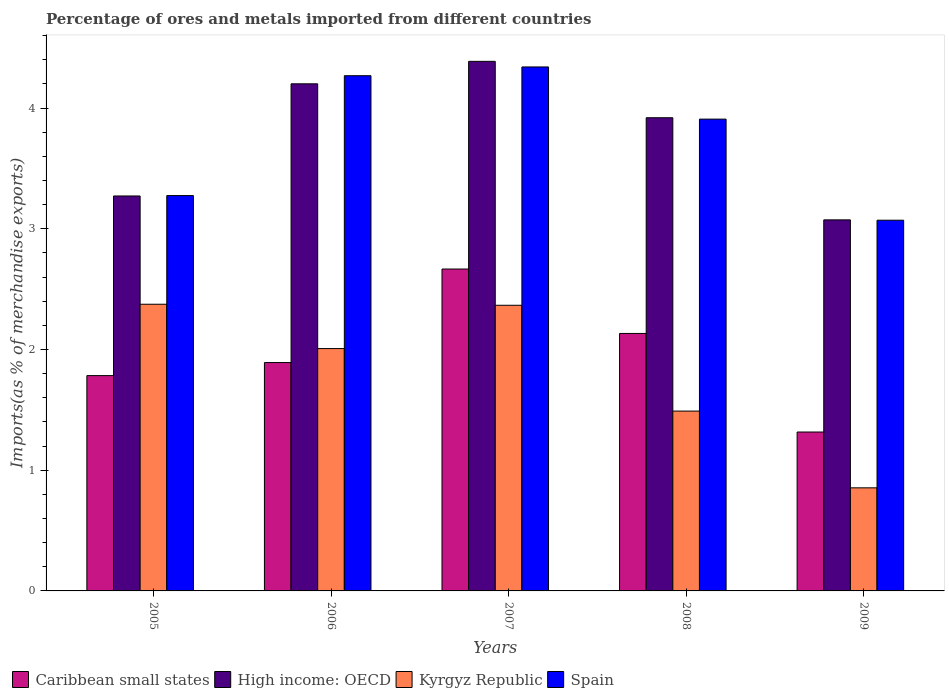How many different coloured bars are there?
Provide a short and direct response. 4. How many groups of bars are there?
Make the answer very short. 5. Are the number of bars per tick equal to the number of legend labels?
Your answer should be compact. Yes. What is the percentage of imports to different countries in High income: OECD in 2008?
Give a very brief answer. 3.92. Across all years, what is the maximum percentage of imports to different countries in Spain?
Keep it short and to the point. 4.34. Across all years, what is the minimum percentage of imports to different countries in Kyrgyz Republic?
Offer a terse response. 0.85. In which year was the percentage of imports to different countries in Kyrgyz Republic maximum?
Ensure brevity in your answer.  2005. In which year was the percentage of imports to different countries in High income: OECD minimum?
Your answer should be very brief. 2009. What is the total percentage of imports to different countries in Kyrgyz Republic in the graph?
Provide a succinct answer. 9.09. What is the difference between the percentage of imports to different countries in High income: OECD in 2007 and that in 2008?
Make the answer very short. 0.47. What is the difference between the percentage of imports to different countries in Kyrgyz Republic in 2007 and the percentage of imports to different countries in High income: OECD in 2008?
Your response must be concise. -1.55. What is the average percentage of imports to different countries in High income: OECD per year?
Your response must be concise. 3.77. In the year 2008, what is the difference between the percentage of imports to different countries in High income: OECD and percentage of imports to different countries in Kyrgyz Republic?
Your response must be concise. 2.43. What is the ratio of the percentage of imports to different countries in Caribbean small states in 2005 to that in 2006?
Offer a very short reply. 0.94. Is the difference between the percentage of imports to different countries in High income: OECD in 2005 and 2009 greater than the difference between the percentage of imports to different countries in Kyrgyz Republic in 2005 and 2009?
Offer a terse response. No. What is the difference between the highest and the second highest percentage of imports to different countries in Spain?
Your response must be concise. 0.07. What is the difference between the highest and the lowest percentage of imports to different countries in High income: OECD?
Your answer should be very brief. 1.31. In how many years, is the percentage of imports to different countries in High income: OECD greater than the average percentage of imports to different countries in High income: OECD taken over all years?
Your answer should be very brief. 3. Is the sum of the percentage of imports to different countries in Caribbean small states in 2008 and 2009 greater than the maximum percentage of imports to different countries in High income: OECD across all years?
Your answer should be very brief. No. Is it the case that in every year, the sum of the percentage of imports to different countries in Kyrgyz Republic and percentage of imports to different countries in Spain is greater than the sum of percentage of imports to different countries in Caribbean small states and percentage of imports to different countries in High income: OECD?
Your answer should be very brief. Yes. What does the 1st bar from the left in 2008 represents?
Provide a short and direct response. Caribbean small states. What does the 4th bar from the right in 2007 represents?
Offer a terse response. Caribbean small states. Are all the bars in the graph horizontal?
Offer a very short reply. No. What is the difference between two consecutive major ticks on the Y-axis?
Your answer should be very brief. 1. Does the graph contain grids?
Offer a terse response. No. Where does the legend appear in the graph?
Offer a terse response. Bottom left. What is the title of the graph?
Ensure brevity in your answer.  Percentage of ores and metals imported from different countries. Does "Cambodia" appear as one of the legend labels in the graph?
Provide a succinct answer. No. What is the label or title of the Y-axis?
Your response must be concise. Imports(as % of merchandise exports). What is the Imports(as % of merchandise exports) of Caribbean small states in 2005?
Your answer should be compact. 1.78. What is the Imports(as % of merchandise exports) of High income: OECD in 2005?
Offer a terse response. 3.27. What is the Imports(as % of merchandise exports) of Kyrgyz Republic in 2005?
Your answer should be very brief. 2.37. What is the Imports(as % of merchandise exports) of Spain in 2005?
Your response must be concise. 3.28. What is the Imports(as % of merchandise exports) of Caribbean small states in 2006?
Provide a succinct answer. 1.89. What is the Imports(as % of merchandise exports) of High income: OECD in 2006?
Ensure brevity in your answer.  4.2. What is the Imports(as % of merchandise exports) of Kyrgyz Republic in 2006?
Give a very brief answer. 2.01. What is the Imports(as % of merchandise exports) in Spain in 2006?
Offer a terse response. 4.27. What is the Imports(as % of merchandise exports) in Caribbean small states in 2007?
Your answer should be compact. 2.67. What is the Imports(as % of merchandise exports) in High income: OECD in 2007?
Provide a succinct answer. 4.39. What is the Imports(as % of merchandise exports) of Kyrgyz Republic in 2007?
Keep it short and to the point. 2.37. What is the Imports(as % of merchandise exports) of Spain in 2007?
Keep it short and to the point. 4.34. What is the Imports(as % of merchandise exports) in Caribbean small states in 2008?
Make the answer very short. 2.13. What is the Imports(as % of merchandise exports) of High income: OECD in 2008?
Your answer should be compact. 3.92. What is the Imports(as % of merchandise exports) of Kyrgyz Republic in 2008?
Your answer should be very brief. 1.49. What is the Imports(as % of merchandise exports) in Spain in 2008?
Ensure brevity in your answer.  3.91. What is the Imports(as % of merchandise exports) of Caribbean small states in 2009?
Offer a very short reply. 1.32. What is the Imports(as % of merchandise exports) in High income: OECD in 2009?
Offer a terse response. 3.07. What is the Imports(as % of merchandise exports) of Kyrgyz Republic in 2009?
Keep it short and to the point. 0.85. What is the Imports(as % of merchandise exports) of Spain in 2009?
Your answer should be compact. 3.07. Across all years, what is the maximum Imports(as % of merchandise exports) of Caribbean small states?
Keep it short and to the point. 2.67. Across all years, what is the maximum Imports(as % of merchandise exports) in High income: OECD?
Provide a succinct answer. 4.39. Across all years, what is the maximum Imports(as % of merchandise exports) in Kyrgyz Republic?
Give a very brief answer. 2.37. Across all years, what is the maximum Imports(as % of merchandise exports) of Spain?
Offer a terse response. 4.34. Across all years, what is the minimum Imports(as % of merchandise exports) of Caribbean small states?
Make the answer very short. 1.32. Across all years, what is the minimum Imports(as % of merchandise exports) in High income: OECD?
Your answer should be compact. 3.07. Across all years, what is the minimum Imports(as % of merchandise exports) in Kyrgyz Republic?
Ensure brevity in your answer.  0.85. Across all years, what is the minimum Imports(as % of merchandise exports) of Spain?
Give a very brief answer. 3.07. What is the total Imports(as % of merchandise exports) in Caribbean small states in the graph?
Give a very brief answer. 9.79. What is the total Imports(as % of merchandise exports) in High income: OECD in the graph?
Make the answer very short. 18.85. What is the total Imports(as % of merchandise exports) in Kyrgyz Republic in the graph?
Ensure brevity in your answer.  9.09. What is the total Imports(as % of merchandise exports) of Spain in the graph?
Ensure brevity in your answer.  18.86. What is the difference between the Imports(as % of merchandise exports) of Caribbean small states in 2005 and that in 2006?
Your answer should be very brief. -0.11. What is the difference between the Imports(as % of merchandise exports) of High income: OECD in 2005 and that in 2006?
Ensure brevity in your answer.  -0.93. What is the difference between the Imports(as % of merchandise exports) in Kyrgyz Republic in 2005 and that in 2006?
Make the answer very short. 0.37. What is the difference between the Imports(as % of merchandise exports) in Spain in 2005 and that in 2006?
Your answer should be very brief. -0.99. What is the difference between the Imports(as % of merchandise exports) of Caribbean small states in 2005 and that in 2007?
Give a very brief answer. -0.88. What is the difference between the Imports(as % of merchandise exports) in High income: OECD in 2005 and that in 2007?
Offer a terse response. -1.12. What is the difference between the Imports(as % of merchandise exports) in Kyrgyz Republic in 2005 and that in 2007?
Your response must be concise. 0.01. What is the difference between the Imports(as % of merchandise exports) of Spain in 2005 and that in 2007?
Give a very brief answer. -1.07. What is the difference between the Imports(as % of merchandise exports) of Caribbean small states in 2005 and that in 2008?
Give a very brief answer. -0.35. What is the difference between the Imports(as % of merchandise exports) of High income: OECD in 2005 and that in 2008?
Your response must be concise. -0.65. What is the difference between the Imports(as % of merchandise exports) of Kyrgyz Republic in 2005 and that in 2008?
Provide a short and direct response. 0.89. What is the difference between the Imports(as % of merchandise exports) of Spain in 2005 and that in 2008?
Provide a succinct answer. -0.63. What is the difference between the Imports(as % of merchandise exports) in Caribbean small states in 2005 and that in 2009?
Make the answer very short. 0.47. What is the difference between the Imports(as % of merchandise exports) in High income: OECD in 2005 and that in 2009?
Your answer should be compact. 0.2. What is the difference between the Imports(as % of merchandise exports) of Kyrgyz Republic in 2005 and that in 2009?
Your answer should be compact. 1.52. What is the difference between the Imports(as % of merchandise exports) of Spain in 2005 and that in 2009?
Your answer should be compact. 0.2. What is the difference between the Imports(as % of merchandise exports) in Caribbean small states in 2006 and that in 2007?
Give a very brief answer. -0.77. What is the difference between the Imports(as % of merchandise exports) in High income: OECD in 2006 and that in 2007?
Ensure brevity in your answer.  -0.19. What is the difference between the Imports(as % of merchandise exports) of Kyrgyz Republic in 2006 and that in 2007?
Provide a succinct answer. -0.36. What is the difference between the Imports(as % of merchandise exports) in Spain in 2006 and that in 2007?
Provide a succinct answer. -0.07. What is the difference between the Imports(as % of merchandise exports) of Caribbean small states in 2006 and that in 2008?
Offer a very short reply. -0.24. What is the difference between the Imports(as % of merchandise exports) in High income: OECD in 2006 and that in 2008?
Give a very brief answer. 0.28. What is the difference between the Imports(as % of merchandise exports) of Kyrgyz Republic in 2006 and that in 2008?
Offer a very short reply. 0.52. What is the difference between the Imports(as % of merchandise exports) in Spain in 2006 and that in 2008?
Offer a terse response. 0.36. What is the difference between the Imports(as % of merchandise exports) in Caribbean small states in 2006 and that in 2009?
Your answer should be compact. 0.58. What is the difference between the Imports(as % of merchandise exports) in High income: OECD in 2006 and that in 2009?
Your answer should be compact. 1.13. What is the difference between the Imports(as % of merchandise exports) in Kyrgyz Republic in 2006 and that in 2009?
Your answer should be compact. 1.15. What is the difference between the Imports(as % of merchandise exports) in Spain in 2006 and that in 2009?
Keep it short and to the point. 1.2. What is the difference between the Imports(as % of merchandise exports) of Caribbean small states in 2007 and that in 2008?
Provide a succinct answer. 0.53. What is the difference between the Imports(as % of merchandise exports) of High income: OECD in 2007 and that in 2008?
Offer a terse response. 0.47. What is the difference between the Imports(as % of merchandise exports) of Kyrgyz Republic in 2007 and that in 2008?
Make the answer very short. 0.88. What is the difference between the Imports(as % of merchandise exports) of Spain in 2007 and that in 2008?
Ensure brevity in your answer.  0.43. What is the difference between the Imports(as % of merchandise exports) of Caribbean small states in 2007 and that in 2009?
Your response must be concise. 1.35. What is the difference between the Imports(as % of merchandise exports) of High income: OECD in 2007 and that in 2009?
Offer a very short reply. 1.31. What is the difference between the Imports(as % of merchandise exports) of Kyrgyz Republic in 2007 and that in 2009?
Provide a short and direct response. 1.51. What is the difference between the Imports(as % of merchandise exports) in Spain in 2007 and that in 2009?
Offer a very short reply. 1.27. What is the difference between the Imports(as % of merchandise exports) of Caribbean small states in 2008 and that in 2009?
Provide a succinct answer. 0.82. What is the difference between the Imports(as % of merchandise exports) in High income: OECD in 2008 and that in 2009?
Ensure brevity in your answer.  0.85. What is the difference between the Imports(as % of merchandise exports) in Kyrgyz Republic in 2008 and that in 2009?
Ensure brevity in your answer.  0.64. What is the difference between the Imports(as % of merchandise exports) in Spain in 2008 and that in 2009?
Your response must be concise. 0.84. What is the difference between the Imports(as % of merchandise exports) in Caribbean small states in 2005 and the Imports(as % of merchandise exports) in High income: OECD in 2006?
Make the answer very short. -2.42. What is the difference between the Imports(as % of merchandise exports) of Caribbean small states in 2005 and the Imports(as % of merchandise exports) of Kyrgyz Republic in 2006?
Provide a succinct answer. -0.22. What is the difference between the Imports(as % of merchandise exports) of Caribbean small states in 2005 and the Imports(as % of merchandise exports) of Spain in 2006?
Make the answer very short. -2.48. What is the difference between the Imports(as % of merchandise exports) of High income: OECD in 2005 and the Imports(as % of merchandise exports) of Kyrgyz Republic in 2006?
Offer a very short reply. 1.26. What is the difference between the Imports(as % of merchandise exports) in High income: OECD in 2005 and the Imports(as % of merchandise exports) in Spain in 2006?
Make the answer very short. -1. What is the difference between the Imports(as % of merchandise exports) of Kyrgyz Republic in 2005 and the Imports(as % of merchandise exports) of Spain in 2006?
Your response must be concise. -1.89. What is the difference between the Imports(as % of merchandise exports) in Caribbean small states in 2005 and the Imports(as % of merchandise exports) in High income: OECD in 2007?
Give a very brief answer. -2.6. What is the difference between the Imports(as % of merchandise exports) in Caribbean small states in 2005 and the Imports(as % of merchandise exports) in Kyrgyz Republic in 2007?
Your answer should be compact. -0.58. What is the difference between the Imports(as % of merchandise exports) in Caribbean small states in 2005 and the Imports(as % of merchandise exports) in Spain in 2007?
Your response must be concise. -2.56. What is the difference between the Imports(as % of merchandise exports) in High income: OECD in 2005 and the Imports(as % of merchandise exports) in Kyrgyz Republic in 2007?
Provide a short and direct response. 0.91. What is the difference between the Imports(as % of merchandise exports) of High income: OECD in 2005 and the Imports(as % of merchandise exports) of Spain in 2007?
Give a very brief answer. -1.07. What is the difference between the Imports(as % of merchandise exports) of Kyrgyz Republic in 2005 and the Imports(as % of merchandise exports) of Spain in 2007?
Provide a short and direct response. -1.97. What is the difference between the Imports(as % of merchandise exports) of Caribbean small states in 2005 and the Imports(as % of merchandise exports) of High income: OECD in 2008?
Ensure brevity in your answer.  -2.14. What is the difference between the Imports(as % of merchandise exports) of Caribbean small states in 2005 and the Imports(as % of merchandise exports) of Kyrgyz Republic in 2008?
Your response must be concise. 0.29. What is the difference between the Imports(as % of merchandise exports) of Caribbean small states in 2005 and the Imports(as % of merchandise exports) of Spain in 2008?
Ensure brevity in your answer.  -2.12. What is the difference between the Imports(as % of merchandise exports) of High income: OECD in 2005 and the Imports(as % of merchandise exports) of Kyrgyz Republic in 2008?
Make the answer very short. 1.78. What is the difference between the Imports(as % of merchandise exports) in High income: OECD in 2005 and the Imports(as % of merchandise exports) in Spain in 2008?
Provide a succinct answer. -0.64. What is the difference between the Imports(as % of merchandise exports) of Kyrgyz Republic in 2005 and the Imports(as % of merchandise exports) of Spain in 2008?
Your answer should be very brief. -1.53. What is the difference between the Imports(as % of merchandise exports) of Caribbean small states in 2005 and the Imports(as % of merchandise exports) of High income: OECD in 2009?
Ensure brevity in your answer.  -1.29. What is the difference between the Imports(as % of merchandise exports) of Caribbean small states in 2005 and the Imports(as % of merchandise exports) of Kyrgyz Republic in 2009?
Make the answer very short. 0.93. What is the difference between the Imports(as % of merchandise exports) in Caribbean small states in 2005 and the Imports(as % of merchandise exports) in Spain in 2009?
Offer a very short reply. -1.29. What is the difference between the Imports(as % of merchandise exports) in High income: OECD in 2005 and the Imports(as % of merchandise exports) in Kyrgyz Republic in 2009?
Provide a succinct answer. 2.42. What is the difference between the Imports(as % of merchandise exports) of High income: OECD in 2005 and the Imports(as % of merchandise exports) of Spain in 2009?
Offer a terse response. 0.2. What is the difference between the Imports(as % of merchandise exports) of Kyrgyz Republic in 2005 and the Imports(as % of merchandise exports) of Spain in 2009?
Give a very brief answer. -0.7. What is the difference between the Imports(as % of merchandise exports) in Caribbean small states in 2006 and the Imports(as % of merchandise exports) in High income: OECD in 2007?
Make the answer very short. -2.5. What is the difference between the Imports(as % of merchandise exports) in Caribbean small states in 2006 and the Imports(as % of merchandise exports) in Kyrgyz Republic in 2007?
Your answer should be very brief. -0.47. What is the difference between the Imports(as % of merchandise exports) in Caribbean small states in 2006 and the Imports(as % of merchandise exports) in Spain in 2007?
Your response must be concise. -2.45. What is the difference between the Imports(as % of merchandise exports) of High income: OECD in 2006 and the Imports(as % of merchandise exports) of Kyrgyz Republic in 2007?
Make the answer very short. 1.83. What is the difference between the Imports(as % of merchandise exports) of High income: OECD in 2006 and the Imports(as % of merchandise exports) of Spain in 2007?
Your response must be concise. -0.14. What is the difference between the Imports(as % of merchandise exports) of Kyrgyz Republic in 2006 and the Imports(as % of merchandise exports) of Spain in 2007?
Provide a succinct answer. -2.33. What is the difference between the Imports(as % of merchandise exports) of Caribbean small states in 2006 and the Imports(as % of merchandise exports) of High income: OECD in 2008?
Make the answer very short. -2.03. What is the difference between the Imports(as % of merchandise exports) in Caribbean small states in 2006 and the Imports(as % of merchandise exports) in Kyrgyz Republic in 2008?
Offer a terse response. 0.4. What is the difference between the Imports(as % of merchandise exports) in Caribbean small states in 2006 and the Imports(as % of merchandise exports) in Spain in 2008?
Ensure brevity in your answer.  -2.02. What is the difference between the Imports(as % of merchandise exports) in High income: OECD in 2006 and the Imports(as % of merchandise exports) in Kyrgyz Republic in 2008?
Provide a succinct answer. 2.71. What is the difference between the Imports(as % of merchandise exports) of High income: OECD in 2006 and the Imports(as % of merchandise exports) of Spain in 2008?
Provide a succinct answer. 0.29. What is the difference between the Imports(as % of merchandise exports) in Kyrgyz Republic in 2006 and the Imports(as % of merchandise exports) in Spain in 2008?
Keep it short and to the point. -1.9. What is the difference between the Imports(as % of merchandise exports) of Caribbean small states in 2006 and the Imports(as % of merchandise exports) of High income: OECD in 2009?
Offer a terse response. -1.18. What is the difference between the Imports(as % of merchandise exports) in Caribbean small states in 2006 and the Imports(as % of merchandise exports) in Kyrgyz Republic in 2009?
Provide a succinct answer. 1.04. What is the difference between the Imports(as % of merchandise exports) of Caribbean small states in 2006 and the Imports(as % of merchandise exports) of Spain in 2009?
Keep it short and to the point. -1.18. What is the difference between the Imports(as % of merchandise exports) of High income: OECD in 2006 and the Imports(as % of merchandise exports) of Kyrgyz Republic in 2009?
Make the answer very short. 3.35. What is the difference between the Imports(as % of merchandise exports) in High income: OECD in 2006 and the Imports(as % of merchandise exports) in Spain in 2009?
Ensure brevity in your answer.  1.13. What is the difference between the Imports(as % of merchandise exports) of Kyrgyz Republic in 2006 and the Imports(as % of merchandise exports) of Spain in 2009?
Ensure brevity in your answer.  -1.06. What is the difference between the Imports(as % of merchandise exports) of Caribbean small states in 2007 and the Imports(as % of merchandise exports) of High income: OECD in 2008?
Your answer should be very brief. -1.25. What is the difference between the Imports(as % of merchandise exports) in Caribbean small states in 2007 and the Imports(as % of merchandise exports) in Kyrgyz Republic in 2008?
Provide a succinct answer. 1.18. What is the difference between the Imports(as % of merchandise exports) of Caribbean small states in 2007 and the Imports(as % of merchandise exports) of Spain in 2008?
Offer a very short reply. -1.24. What is the difference between the Imports(as % of merchandise exports) in High income: OECD in 2007 and the Imports(as % of merchandise exports) in Kyrgyz Republic in 2008?
Your answer should be very brief. 2.9. What is the difference between the Imports(as % of merchandise exports) in High income: OECD in 2007 and the Imports(as % of merchandise exports) in Spain in 2008?
Keep it short and to the point. 0.48. What is the difference between the Imports(as % of merchandise exports) in Kyrgyz Republic in 2007 and the Imports(as % of merchandise exports) in Spain in 2008?
Your response must be concise. -1.54. What is the difference between the Imports(as % of merchandise exports) of Caribbean small states in 2007 and the Imports(as % of merchandise exports) of High income: OECD in 2009?
Give a very brief answer. -0.41. What is the difference between the Imports(as % of merchandise exports) in Caribbean small states in 2007 and the Imports(as % of merchandise exports) in Kyrgyz Republic in 2009?
Ensure brevity in your answer.  1.81. What is the difference between the Imports(as % of merchandise exports) in Caribbean small states in 2007 and the Imports(as % of merchandise exports) in Spain in 2009?
Give a very brief answer. -0.4. What is the difference between the Imports(as % of merchandise exports) in High income: OECD in 2007 and the Imports(as % of merchandise exports) in Kyrgyz Republic in 2009?
Offer a very short reply. 3.53. What is the difference between the Imports(as % of merchandise exports) of High income: OECD in 2007 and the Imports(as % of merchandise exports) of Spain in 2009?
Provide a short and direct response. 1.32. What is the difference between the Imports(as % of merchandise exports) in Kyrgyz Republic in 2007 and the Imports(as % of merchandise exports) in Spain in 2009?
Your answer should be compact. -0.7. What is the difference between the Imports(as % of merchandise exports) of Caribbean small states in 2008 and the Imports(as % of merchandise exports) of High income: OECD in 2009?
Offer a terse response. -0.94. What is the difference between the Imports(as % of merchandise exports) in Caribbean small states in 2008 and the Imports(as % of merchandise exports) in Kyrgyz Republic in 2009?
Your response must be concise. 1.28. What is the difference between the Imports(as % of merchandise exports) of Caribbean small states in 2008 and the Imports(as % of merchandise exports) of Spain in 2009?
Offer a very short reply. -0.94. What is the difference between the Imports(as % of merchandise exports) in High income: OECD in 2008 and the Imports(as % of merchandise exports) in Kyrgyz Republic in 2009?
Give a very brief answer. 3.07. What is the difference between the Imports(as % of merchandise exports) of High income: OECD in 2008 and the Imports(as % of merchandise exports) of Spain in 2009?
Your answer should be compact. 0.85. What is the difference between the Imports(as % of merchandise exports) of Kyrgyz Republic in 2008 and the Imports(as % of merchandise exports) of Spain in 2009?
Give a very brief answer. -1.58. What is the average Imports(as % of merchandise exports) in Caribbean small states per year?
Your response must be concise. 1.96. What is the average Imports(as % of merchandise exports) of High income: OECD per year?
Your answer should be very brief. 3.77. What is the average Imports(as % of merchandise exports) in Kyrgyz Republic per year?
Give a very brief answer. 1.82. What is the average Imports(as % of merchandise exports) in Spain per year?
Provide a short and direct response. 3.77. In the year 2005, what is the difference between the Imports(as % of merchandise exports) of Caribbean small states and Imports(as % of merchandise exports) of High income: OECD?
Offer a very short reply. -1.49. In the year 2005, what is the difference between the Imports(as % of merchandise exports) of Caribbean small states and Imports(as % of merchandise exports) of Kyrgyz Republic?
Offer a terse response. -0.59. In the year 2005, what is the difference between the Imports(as % of merchandise exports) in Caribbean small states and Imports(as % of merchandise exports) in Spain?
Provide a succinct answer. -1.49. In the year 2005, what is the difference between the Imports(as % of merchandise exports) in High income: OECD and Imports(as % of merchandise exports) in Kyrgyz Republic?
Give a very brief answer. 0.9. In the year 2005, what is the difference between the Imports(as % of merchandise exports) of High income: OECD and Imports(as % of merchandise exports) of Spain?
Keep it short and to the point. -0. In the year 2005, what is the difference between the Imports(as % of merchandise exports) of Kyrgyz Republic and Imports(as % of merchandise exports) of Spain?
Give a very brief answer. -0.9. In the year 2006, what is the difference between the Imports(as % of merchandise exports) of Caribbean small states and Imports(as % of merchandise exports) of High income: OECD?
Keep it short and to the point. -2.31. In the year 2006, what is the difference between the Imports(as % of merchandise exports) in Caribbean small states and Imports(as % of merchandise exports) in Kyrgyz Republic?
Provide a succinct answer. -0.12. In the year 2006, what is the difference between the Imports(as % of merchandise exports) of Caribbean small states and Imports(as % of merchandise exports) of Spain?
Offer a terse response. -2.38. In the year 2006, what is the difference between the Imports(as % of merchandise exports) of High income: OECD and Imports(as % of merchandise exports) of Kyrgyz Republic?
Keep it short and to the point. 2.19. In the year 2006, what is the difference between the Imports(as % of merchandise exports) of High income: OECD and Imports(as % of merchandise exports) of Spain?
Provide a short and direct response. -0.07. In the year 2006, what is the difference between the Imports(as % of merchandise exports) in Kyrgyz Republic and Imports(as % of merchandise exports) in Spain?
Your response must be concise. -2.26. In the year 2007, what is the difference between the Imports(as % of merchandise exports) in Caribbean small states and Imports(as % of merchandise exports) in High income: OECD?
Ensure brevity in your answer.  -1.72. In the year 2007, what is the difference between the Imports(as % of merchandise exports) of Caribbean small states and Imports(as % of merchandise exports) of Kyrgyz Republic?
Your answer should be very brief. 0.3. In the year 2007, what is the difference between the Imports(as % of merchandise exports) in Caribbean small states and Imports(as % of merchandise exports) in Spain?
Your response must be concise. -1.67. In the year 2007, what is the difference between the Imports(as % of merchandise exports) in High income: OECD and Imports(as % of merchandise exports) in Kyrgyz Republic?
Provide a short and direct response. 2.02. In the year 2007, what is the difference between the Imports(as % of merchandise exports) of High income: OECD and Imports(as % of merchandise exports) of Spain?
Your answer should be very brief. 0.05. In the year 2007, what is the difference between the Imports(as % of merchandise exports) of Kyrgyz Republic and Imports(as % of merchandise exports) of Spain?
Your answer should be compact. -1.97. In the year 2008, what is the difference between the Imports(as % of merchandise exports) of Caribbean small states and Imports(as % of merchandise exports) of High income: OECD?
Offer a very short reply. -1.79. In the year 2008, what is the difference between the Imports(as % of merchandise exports) in Caribbean small states and Imports(as % of merchandise exports) in Kyrgyz Republic?
Provide a short and direct response. 0.64. In the year 2008, what is the difference between the Imports(as % of merchandise exports) of Caribbean small states and Imports(as % of merchandise exports) of Spain?
Offer a very short reply. -1.78. In the year 2008, what is the difference between the Imports(as % of merchandise exports) in High income: OECD and Imports(as % of merchandise exports) in Kyrgyz Republic?
Keep it short and to the point. 2.43. In the year 2008, what is the difference between the Imports(as % of merchandise exports) of High income: OECD and Imports(as % of merchandise exports) of Spain?
Keep it short and to the point. 0.01. In the year 2008, what is the difference between the Imports(as % of merchandise exports) in Kyrgyz Republic and Imports(as % of merchandise exports) in Spain?
Make the answer very short. -2.42. In the year 2009, what is the difference between the Imports(as % of merchandise exports) of Caribbean small states and Imports(as % of merchandise exports) of High income: OECD?
Offer a terse response. -1.76. In the year 2009, what is the difference between the Imports(as % of merchandise exports) of Caribbean small states and Imports(as % of merchandise exports) of Kyrgyz Republic?
Provide a short and direct response. 0.46. In the year 2009, what is the difference between the Imports(as % of merchandise exports) in Caribbean small states and Imports(as % of merchandise exports) in Spain?
Offer a very short reply. -1.75. In the year 2009, what is the difference between the Imports(as % of merchandise exports) in High income: OECD and Imports(as % of merchandise exports) in Kyrgyz Republic?
Keep it short and to the point. 2.22. In the year 2009, what is the difference between the Imports(as % of merchandise exports) in High income: OECD and Imports(as % of merchandise exports) in Spain?
Offer a very short reply. 0. In the year 2009, what is the difference between the Imports(as % of merchandise exports) of Kyrgyz Republic and Imports(as % of merchandise exports) of Spain?
Provide a succinct answer. -2.22. What is the ratio of the Imports(as % of merchandise exports) in Caribbean small states in 2005 to that in 2006?
Offer a terse response. 0.94. What is the ratio of the Imports(as % of merchandise exports) in High income: OECD in 2005 to that in 2006?
Provide a succinct answer. 0.78. What is the ratio of the Imports(as % of merchandise exports) of Kyrgyz Republic in 2005 to that in 2006?
Provide a short and direct response. 1.18. What is the ratio of the Imports(as % of merchandise exports) of Spain in 2005 to that in 2006?
Your response must be concise. 0.77. What is the ratio of the Imports(as % of merchandise exports) in Caribbean small states in 2005 to that in 2007?
Ensure brevity in your answer.  0.67. What is the ratio of the Imports(as % of merchandise exports) in High income: OECD in 2005 to that in 2007?
Your answer should be very brief. 0.75. What is the ratio of the Imports(as % of merchandise exports) in Spain in 2005 to that in 2007?
Offer a very short reply. 0.75. What is the ratio of the Imports(as % of merchandise exports) of Caribbean small states in 2005 to that in 2008?
Make the answer very short. 0.84. What is the ratio of the Imports(as % of merchandise exports) in High income: OECD in 2005 to that in 2008?
Give a very brief answer. 0.83. What is the ratio of the Imports(as % of merchandise exports) in Kyrgyz Republic in 2005 to that in 2008?
Your response must be concise. 1.59. What is the ratio of the Imports(as % of merchandise exports) in Spain in 2005 to that in 2008?
Make the answer very short. 0.84. What is the ratio of the Imports(as % of merchandise exports) of Caribbean small states in 2005 to that in 2009?
Provide a short and direct response. 1.36. What is the ratio of the Imports(as % of merchandise exports) of High income: OECD in 2005 to that in 2009?
Your answer should be very brief. 1.06. What is the ratio of the Imports(as % of merchandise exports) in Kyrgyz Republic in 2005 to that in 2009?
Your answer should be very brief. 2.78. What is the ratio of the Imports(as % of merchandise exports) of Spain in 2005 to that in 2009?
Keep it short and to the point. 1.07. What is the ratio of the Imports(as % of merchandise exports) of Caribbean small states in 2006 to that in 2007?
Offer a very short reply. 0.71. What is the ratio of the Imports(as % of merchandise exports) in High income: OECD in 2006 to that in 2007?
Offer a very short reply. 0.96. What is the ratio of the Imports(as % of merchandise exports) of Kyrgyz Republic in 2006 to that in 2007?
Your response must be concise. 0.85. What is the ratio of the Imports(as % of merchandise exports) of Spain in 2006 to that in 2007?
Your response must be concise. 0.98. What is the ratio of the Imports(as % of merchandise exports) of Caribbean small states in 2006 to that in 2008?
Give a very brief answer. 0.89. What is the ratio of the Imports(as % of merchandise exports) in High income: OECD in 2006 to that in 2008?
Your answer should be very brief. 1.07. What is the ratio of the Imports(as % of merchandise exports) of Kyrgyz Republic in 2006 to that in 2008?
Offer a terse response. 1.35. What is the ratio of the Imports(as % of merchandise exports) in Spain in 2006 to that in 2008?
Provide a short and direct response. 1.09. What is the ratio of the Imports(as % of merchandise exports) in Caribbean small states in 2006 to that in 2009?
Offer a very short reply. 1.44. What is the ratio of the Imports(as % of merchandise exports) of High income: OECD in 2006 to that in 2009?
Offer a very short reply. 1.37. What is the ratio of the Imports(as % of merchandise exports) of Kyrgyz Republic in 2006 to that in 2009?
Offer a very short reply. 2.35. What is the ratio of the Imports(as % of merchandise exports) in Spain in 2006 to that in 2009?
Provide a short and direct response. 1.39. What is the ratio of the Imports(as % of merchandise exports) of Caribbean small states in 2007 to that in 2008?
Offer a terse response. 1.25. What is the ratio of the Imports(as % of merchandise exports) of High income: OECD in 2007 to that in 2008?
Your answer should be very brief. 1.12. What is the ratio of the Imports(as % of merchandise exports) in Kyrgyz Republic in 2007 to that in 2008?
Your answer should be compact. 1.59. What is the ratio of the Imports(as % of merchandise exports) in Spain in 2007 to that in 2008?
Your answer should be very brief. 1.11. What is the ratio of the Imports(as % of merchandise exports) of Caribbean small states in 2007 to that in 2009?
Give a very brief answer. 2.03. What is the ratio of the Imports(as % of merchandise exports) of High income: OECD in 2007 to that in 2009?
Offer a very short reply. 1.43. What is the ratio of the Imports(as % of merchandise exports) in Kyrgyz Republic in 2007 to that in 2009?
Make the answer very short. 2.77. What is the ratio of the Imports(as % of merchandise exports) of Spain in 2007 to that in 2009?
Your answer should be compact. 1.41. What is the ratio of the Imports(as % of merchandise exports) in Caribbean small states in 2008 to that in 2009?
Offer a terse response. 1.62. What is the ratio of the Imports(as % of merchandise exports) in High income: OECD in 2008 to that in 2009?
Give a very brief answer. 1.28. What is the ratio of the Imports(as % of merchandise exports) of Kyrgyz Republic in 2008 to that in 2009?
Your answer should be very brief. 1.74. What is the ratio of the Imports(as % of merchandise exports) of Spain in 2008 to that in 2009?
Provide a short and direct response. 1.27. What is the difference between the highest and the second highest Imports(as % of merchandise exports) in Caribbean small states?
Ensure brevity in your answer.  0.53. What is the difference between the highest and the second highest Imports(as % of merchandise exports) in High income: OECD?
Offer a very short reply. 0.19. What is the difference between the highest and the second highest Imports(as % of merchandise exports) in Kyrgyz Republic?
Your answer should be compact. 0.01. What is the difference between the highest and the second highest Imports(as % of merchandise exports) of Spain?
Offer a very short reply. 0.07. What is the difference between the highest and the lowest Imports(as % of merchandise exports) in Caribbean small states?
Give a very brief answer. 1.35. What is the difference between the highest and the lowest Imports(as % of merchandise exports) of High income: OECD?
Ensure brevity in your answer.  1.31. What is the difference between the highest and the lowest Imports(as % of merchandise exports) of Kyrgyz Republic?
Give a very brief answer. 1.52. What is the difference between the highest and the lowest Imports(as % of merchandise exports) of Spain?
Offer a terse response. 1.27. 